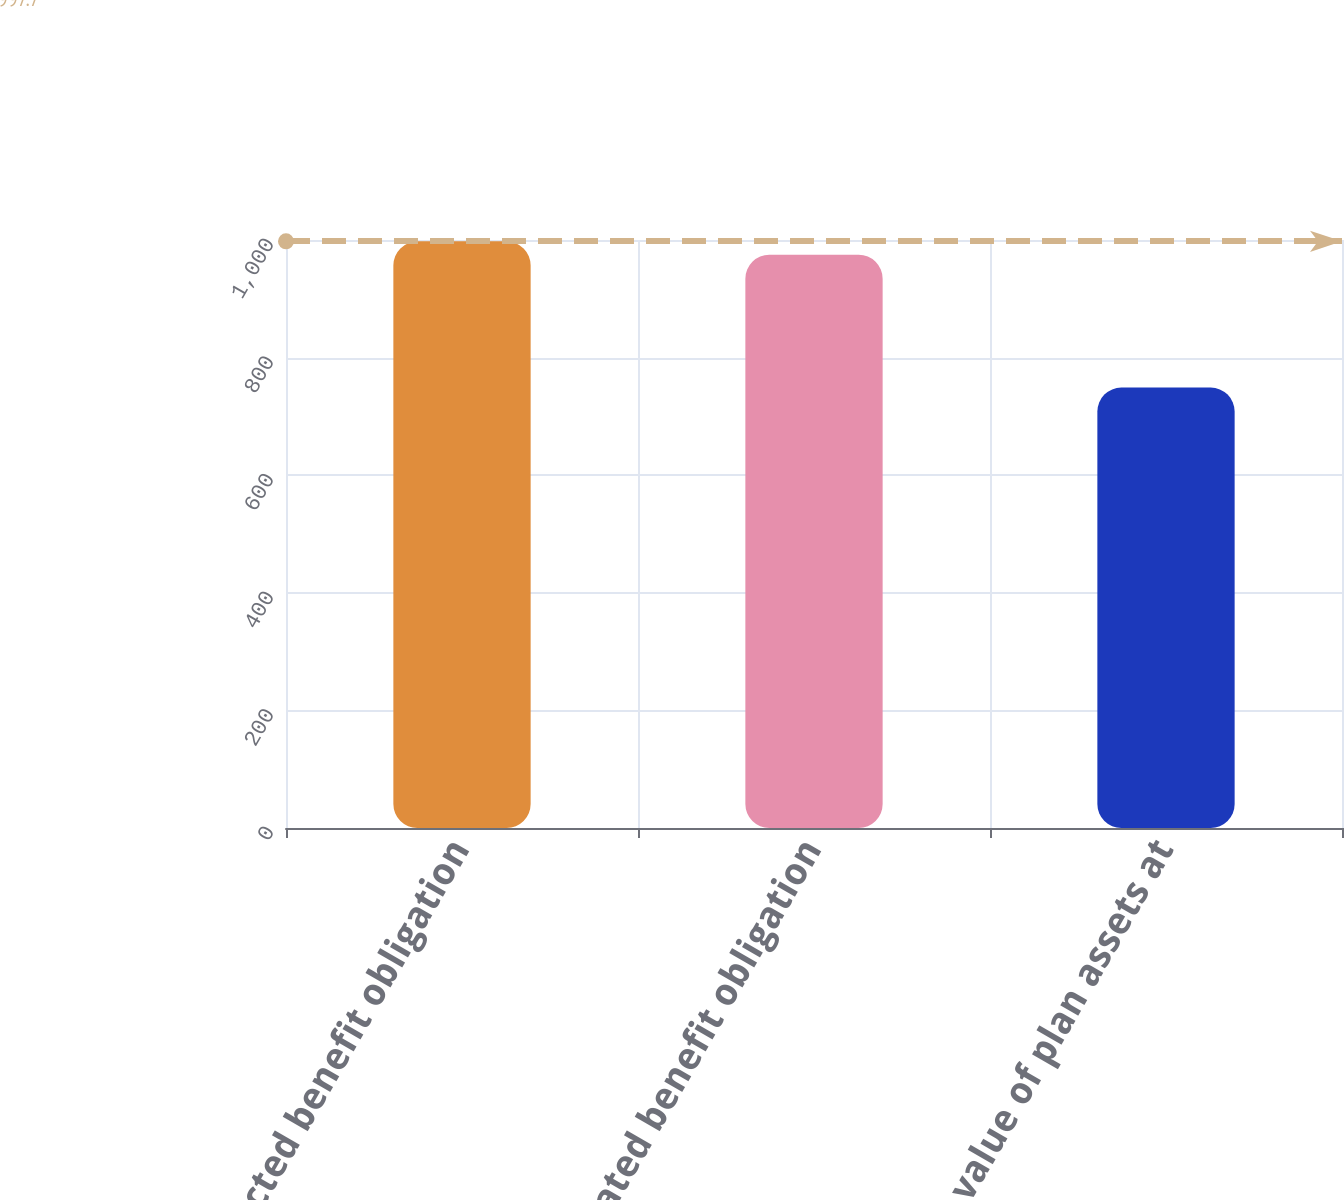Convert chart to OTSL. <chart><loc_0><loc_0><loc_500><loc_500><bar_chart><fcel>Projected benefit obligation<fcel>Accumulated benefit obligation<fcel>Fair value of plan assets at<nl><fcel>997.7<fcel>975<fcel>749<nl></chart> 